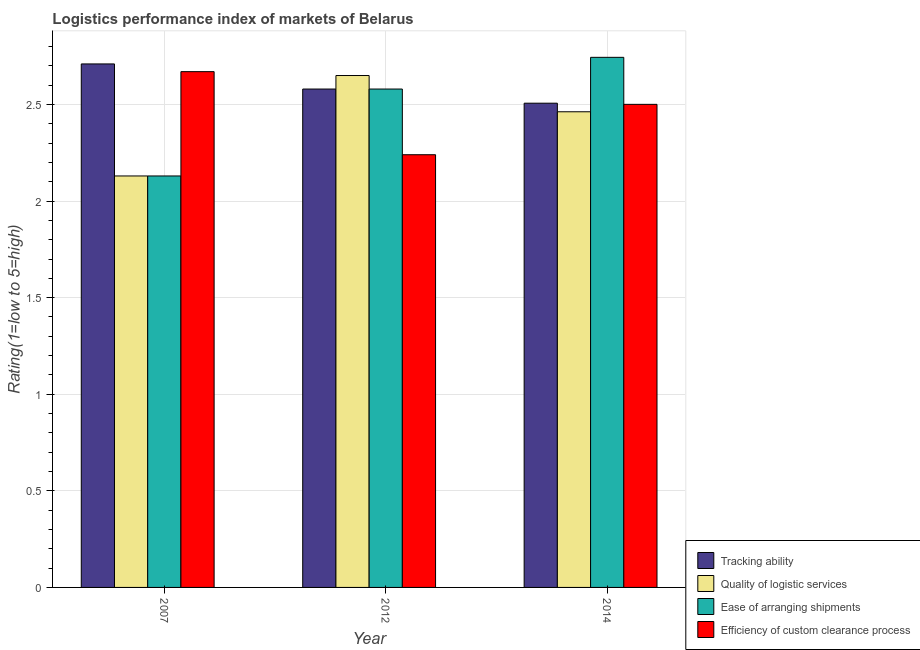How many different coloured bars are there?
Make the answer very short. 4. How many groups of bars are there?
Keep it short and to the point. 3. How many bars are there on the 3rd tick from the left?
Keep it short and to the point. 4. How many bars are there on the 3rd tick from the right?
Offer a very short reply. 4. In how many cases, is the number of bars for a given year not equal to the number of legend labels?
Ensure brevity in your answer.  0. What is the lpi rating of ease of arranging shipments in 2012?
Provide a succinct answer. 2.58. Across all years, what is the maximum lpi rating of ease of arranging shipments?
Offer a terse response. 2.74. Across all years, what is the minimum lpi rating of ease of arranging shipments?
Your response must be concise. 2.13. What is the total lpi rating of ease of arranging shipments in the graph?
Ensure brevity in your answer.  7.45. What is the difference between the lpi rating of ease of arranging shipments in 2007 and that in 2014?
Provide a succinct answer. -0.61. What is the difference between the lpi rating of efficiency of custom clearance process in 2014 and the lpi rating of ease of arranging shipments in 2007?
Your response must be concise. -0.17. What is the average lpi rating of ease of arranging shipments per year?
Your answer should be compact. 2.48. What is the ratio of the lpi rating of tracking ability in 2007 to that in 2012?
Provide a short and direct response. 1.05. Is the lpi rating of tracking ability in 2007 less than that in 2012?
Make the answer very short. No. What is the difference between the highest and the second highest lpi rating of quality of logistic services?
Provide a short and direct response. 0.19. What is the difference between the highest and the lowest lpi rating of quality of logistic services?
Offer a very short reply. 0.52. Is the sum of the lpi rating of ease of arranging shipments in 2007 and 2014 greater than the maximum lpi rating of efficiency of custom clearance process across all years?
Your response must be concise. Yes. Is it the case that in every year, the sum of the lpi rating of tracking ability and lpi rating of quality of logistic services is greater than the sum of lpi rating of efficiency of custom clearance process and lpi rating of ease of arranging shipments?
Keep it short and to the point. No. What does the 4th bar from the left in 2007 represents?
Your answer should be very brief. Efficiency of custom clearance process. What does the 2nd bar from the right in 2007 represents?
Offer a very short reply. Ease of arranging shipments. Is it the case that in every year, the sum of the lpi rating of tracking ability and lpi rating of quality of logistic services is greater than the lpi rating of ease of arranging shipments?
Keep it short and to the point. Yes. Are all the bars in the graph horizontal?
Make the answer very short. No. Does the graph contain any zero values?
Ensure brevity in your answer.  No. How are the legend labels stacked?
Your answer should be compact. Vertical. What is the title of the graph?
Provide a succinct answer. Logistics performance index of markets of Belarus. What is the label or title of the X-axis?
Your response must be concise. Year. What is the label or title of the Y-axis?
Your answer should be compact. Rating(1=low to 5=high). What is the Rating(1=low to 5=high) in Tracking ability in 2007?
Ensure brevity in your answer.  2.71. What is the Rating(1=low to 5=high) of Quality of logistic services in 2007?
Your answer should be compact. 2.13. What is the Rating(1=low to 5=high) in Ease of arranging shipments in 2007?
Make the answer very short. 2.13. What is the Rating(1=low to 5=high) of Efficiency of custom clearance process in 2007?
Offer a very short reply. 2.67. What is the Rating(1=low to 5=high) in Tracking ability in 2012?
Keep it short and to the point. 2.58. What is the Rating(1=low to 5=high) of Quality of logistic services in 2012?
Provide a succinct answer. 2.65. What is the Rating(1=low to 5=high) of Ease of arranging shipments in 2012?
Keep it short and to the point. 2.58. What is the Rating(1=low to 5=high) in Efficiency of custom clearance process in 2012?
Your response must be concise. 2.24. What is the Rating(1=low to 5=high) of Tracking ability in 2014?
Keep it short and to the point. 2.51. What is the Rating(1=low to 5=high) of Quality of logistic services in 2014?
Offer a terse response. 2.46. What is the Rating(1=low to 5=high) in Ease of arranging shipments in 2014?
Provide a short and direct response. 2.74. What is the Rating(1=low to 5=high) of Efficiency of custom clearance process in 2014?
Offer a very short reply. 2.5. Across all years, what is the maximum Rating(1=low to 5=high) of Tracking ability?
Your answer should be compact. 2.71. Across all years, what is the maximum Rating(1=low to 5=high) in Quality of logistic services?
Make the answer very short. 2.65. Across all years, what is the maximum Rating(1=low to 5=high) in Ease of arranging shipments?
Offer a very short reply. 2.74. Across all years, what is the maximum Rating(1=low to 5=high) in Efficiency of custom clearance process?
Your answer should be very brief. 2.67. Across all years, what is the minimum Rating(1=low to 5=high) of Tracking ability?
Your answer should be compact. 2.51. Across all years, what is the minimum Rating(1=low to 5=high) of Quality of logistic services?
Your answer should be very brief. 2.13. Across all years, what is the minimum Rating(1=low to 5=high) of Ease of arranging shipments?
Make the answer very short. 2.13. Across all years, what is the minimum Rating(1=low to 5=high) in Efficiency of custom clearance process?
Provide a short and direct response. 2.24. What is the total Rating(1=low to 5=high) of Tracking ability in the graph?
Offer a terse response. 7.8. What is the total Rating(1=low to 5=high) in Quality of logistic services in the graph?
Your response must be concise. 7.24. What is the total Rating(1=low to 5=high) of Ease of arranging shipments in the graph?
Offer a terse response. 7.45. What is the total Rating(1=low to 5=high) in Efficiency of custom clearance process in the graph?
Ensure brevity in your answer.  7.41. What is the difference between the Rating(1=low to 5=high) of Tracking ability in 2007 and that in 2012?
Keep it short and to the point. 0.13. What is the difference between the Rating(1=low to 5=high) of Quality of logistic services in 2007 and that in 2012?
Provide a succinct answer. -0.52. What is the difference between the Rating(1=low to 5=high) of Ease of arranging shipments in 2007 and that in 2012?
Provide a short and direct response. -0.45. What is the difference between the Rating(1=low to 5=high) in Efficiency of custom clearance process in 2007 and that in 2012?
Keep it short and to the point. 0.43. What is the difference between the Rating(1=low to 5=high) of Tracking ability in 2007 and that in 2014?
Offer a terse response. 0.2. What is the difference between the Rating(1=low to 5=high) in Quality of logistic services in 2007 and that in 2014?
Your answer should be very brief. -0.33. What is the difference between the Rating(1=low to 5=high) of Ease of arranging shipments in 2007 and that in 2014?
Provide a succinct answer. -0.61. What is the difference between the Rating(1=low to 5=high) of Efficiency of custom clearance process in 2007 and that in 2014?
Provide a succinct answer. 0.17. What is the difference between the Rating(1=low to 5=high) in Tracking ability in 2012 and that in 2014?
Your response must be concise. 0.07. What is the difference between the Rating(1=low to 5=high) in Quality of logistic services in 2012 and that in 2014?
Make the answer very short. 0.19. What is the difference between the Rating(1=low to 5=high) in Ease of arranging shipments in 2012 and that in 2014?
Your response must be concise. -0.16. What is the difference between the Rating(1=low to 5=high) in Efficiency of custom clearance process in 2012 and that in 2014?
Offer a terse response. -0.26. What is the difference between the Rating(1=low to 5=high) in Tracking ability in 2007 and the Rating(1=low to 5=high) in Ease of arranging shipments in 2012?
Offer a very short reply. 0.13. What is the difference between the Rating(1=low to 5=high) in Tracking ability in 2007 and the Rating(1=low to 5=high) in Efficiency of custom clearance process in 2012?
Make the answer very short. 0.47. What is the difference between the Rating(1=low to 5=high) of Quality of logistic services in 2007 and the Rating(1=low to 5=high) of Ease of arranging shipments in 2012?
Provide a succinct answer. -0.45. What is the difference between the Rating(1=low to 5=high) of Quality of logistic services in 2007 and the Rating(1=low to 5=high) of Efficiency of custom clearance process in 2012?
Provide a short and direct response. -0.11. What is the difference between the Rating(1=low to 5=high) of Ease of arranging shipments in 2007 and the Rating(1=low to 5=high) of Efficiency of custom clearance process in 2012?
Make the answer very short. -0.11. What is the difference between the Rating(1=low to 5=high) in Tracking ability in 2007 and the Rating(1=low to 5=high) in Quality of logistic services in 2014?
Ensure brevity in your answer.  0.25. What is the difference between the Rating(1=low to 5=high) in Tracking ability in 2007 and the Rating(1=low to 5=high) in Ease of arranging shipments in 2014?
Ensure brevity in your answer.  -0.03. What is the difference between the Rating(1=low to 5=high) of Tracking ability in 2007 and the Rating(1=low to 5=high) of Efficiency of custom clearance process in 2014?
Make the answer very short. 0.21. What is the difference between the Rating(1=low to 5=high) of Quality of logistic services in 2007 and the Rating(1=low to 5=high) of Ease of arranging shipments in 2014?
Make the answer very short. -0.61. What is the difference between the Rating(1=low to 5=high) in Quality of logistic services in 2007 and the Rating(1=low to 5=high) in Efficiency of custom clearance process in 2014?
Give a very brief answer. -0.37. What is the difference between the Rating(1=low to 5=high) of Ease of arranging shipments in 2007 and the Rating(1=low to 5=high) of Efficiency of custom clearance process in 2014?
Provide a short and direct response. -0.37. What is the difference between the Rating(1=low to 5=high) in Tracking ability in 2012 and the Rating(1=low to 5=high) in Quality of logistic services in 2014?
Give a very brief answer. 0.12. What is the difference between the Rating(1=low to 5=high) of Tracking ability in 2012 and the Rating(1=low to 5=high) of Ease of arranging shipments in 2014?
Offer a terse response. -0.16. What is the difference between the Rating(1=low to 5=high) in Tracking ability in 2012 and the Rating(1=low to 5=high) in Efficiency of custom clearance process in 2014?
Your answer should be compact. 0.08. What is the difference between the Rating(1=low to 5=high) of Quality of logistic services in 2012 and the Rating(1=low to 5=high) of Ease of arranging shipments in 2014?
Your answer should be very brief. -0.09. What is the difference between the Rating(1=low to 5=high) in Quality of logistic services in 2012 and the Rating(1=low to 5=high) in Efficiency of custom clearance process in 2014?
Give a very brief answer. 0.15. What is the difference between the Rating(1=low to 5=high) of Ease of arranging shipments in 2012 and the Rating(1=low to 5=high) of Efficiency of custom clearance process in 2014?
Make the answer very short. 0.08. What is the average Rating(1=low to 5=high) in Tracking ability per year?
Offer a very short reply. 2.6. What is the average Rating(1=low to 5=high) in Quality of logistic services per year?
Give a very brief answer. 2.41. What is the average Rating(1=low to 5=high) in Ease of arranging shipments per year?
Provide a short and direct response. 2.48. What is the average Rating(1=low to 5=high) of Efficiency of custom clearance process per year?
Your answer should be compact. 2.47. In the year 2007, what is the difference between the Rating(1=low to 5=high) in Tracking ability and Rating(1=low to 5=high) in Quality of logistic services?
Your response must be concise. 0.58. In the year 2007, what is the difference between the Rating(1=low to 5=high) of Tracking ability and Rating(1=low to 5=high) of Ease of arranging shipments?
Provide a short and direct response. 0.58. In the year 2007, what is the difference between the Rating(1=low to 5=high) in Quality of logistic services and Rating(1=low to 5=high) in Ease of arranging shipments?
Keep it short and to the point. 0. In the year 2007, what is the difference between the Rating(1=low to 5=high) of Quality of logistic services and Rating(1=low to 5=high) of Efficiency of custom clearance process?
Offer a very short reply. -0.54. In the year 2007, what is the difference between the Rating(1=low to 5=high) of Ease of arranging shipments and Rating(1=low to 5=high) of Efficiency of custom clearance process?
Give a very brief answer. -0.54. In the year 2012, what is the difference between the Rating(1=low to 5=high) of Tracking ability and Rating(1=low to 5=high) of Quality of logistic services?
Your answer should be compact. -0.07. In the year 2012, what is the difference between the Rating(1=low to 5=high) in Tracking ability and Rating(1=low to 5=high) in Ease of arranging shipments?
Give a very brief answer. 0. In the year 2012, what is the difference between the Rating(1=low to 5=high) of Tracking ability and Rating(1=low to 5=high) of Efficiency of custom clearance process?
Offer a terse response. 0.34. In the year 2012, what is the difference between the Rating(1=low to 5=high) of Quality of logistic services and Rating(1=low to 5=high) of Ease of arranging shipments?
Your answer should be very brief. 0.07. In the year 2012, what is the difference between the Rating(1=low to 5=high) of Quality of logistic services and Rating(1=low to 5=high) of Efficiency of custom clearance process?
Give a very brief answer. 0.41. In the year 2012, what is the difference between the Rating(1=low to 5=high) of Ease of arranging shipments and Rating(1=low to 5=high) of Efficiency of custom clearance process?
Your answer should be very brief. 0.34. In the year 2014, what is the difference between the Rating(1=low to 5=high) in Tracking ability and Rating(1=low to 5=high) in Quality of logistic services?
Give a very brief answer. 0.04. In the year 2014, what is the difference between the Rating(1=low to 5=high) in Tracking ability and Rating(1=low to 5=high) in Ease of arranging shipments?
Your answer should be very brief. -0.24. In the year 2014, what is the difference between the Rating(1=low to 5=high) of Tracking ability and Rating(1=low to 5=high) of Efficiency of custom clearance process?
Your response must be concise. 0.01. In the year 2014, what is the difference between the Rating(1=low to 5=high) in Quality of logistic services and Rating(1=low to 5=high) in Ease of arranging shipments?
Offer a terse response. -0.28. In the year 2014, what is the difference between the Rating(1=low to 5=high) in Quality of logistic services and Rating(1=low to 5=high) in Efficiency of custom clearance process?
Ensure brevity in your answer.  -0.04. In the year 2014, what is the difference between the Rating(1=low to 5=high) in Ease of arranging shipments and Rating(1=low to 5=high) in Efficiency of custom clearance process?
Your response must be concise. 0.24. What is the ratio of the Rating(1=low to 5=high) of Tracking ability in 2007 to that in 2012?
Provide a short and direct response. 1.05. What is the ratio of the Rating(1=low to 5=high) in Quality of logistic services in 2007 to that in 2012?
Your answer should be very brief. 0.8. What is the ratio of the Rating(1=low to 5=high) of Ease of arranging shipments in 2007 to that in 2012?
Your answer should be very brief. 0.83. What is the ratio of the Rating(1=low to 5=high) in Efficiency of custom clearance process in 2007 to that in 2012?
Make the answer very short. 1.19. What is the ratio of the Rating(1=low to 5=high) in Tracking ability in 2007 to that in 2014?
Keep it short and to the point. 1.08. What is the ratio of the Rating(1=low to 5=high) in Quality of logistic services in 2007 to that in 2014?
Your response must be concise. 0.86. What is the ratio of the Rating(1=low to 5=high) in Ease of arranging shipments in 2007 to that in 2014?
Your answer should be very brief. 0.78. What is the ratio of the Rating(1=low to 5=high) of Efficiency of custom clearance process in 2007 to that in 2014?
Offer a terse response. 1.07. What is the ratio of the Rating(1=low to 5=high) of Tracking ability in 2012 to that in 2014?
Your answer should be compact. 1.03. What is the ratio of the Rating(1=low to 5=high) of Quality of logistic services in 2012 to that in 2014?
Ensure brevity in your answer.  1.08. What is the ratio of the Rating(1=low to 5=high) in Ease of arranging shipments in 2012 to that in 2014?
Ensure brevity in your answer.  0.94. What is the ratio of the Rating(1=low to 5=high) of Efficiency of custom clearance process in 2012 to that in 2014?
Your answer should be compact. 0.9. What is the difference between the highest and the second highest Rating(1=low to 5=high) in Tracking ability?
Your response must be concise. 0.13. What is the difference between the highest and the second highest Rating(1=low to 5=high) in Quality of logistic services?
Make the answer very short. 0.19. What is the difference between the highest and the second highest Rating(1=low to 5=high) in Ease of arranging shipments?
Make the answer very short. 0.16. What is the difference between the highest and the second highest Rating(1=low to 5=high) of Efficiency of custom clearance process?
Provide a short and direct response. 0.17. What is the difference between the highest and the lowest Rating(1=low to 5=high) in Tracking ability?
Your answer should be very brief. 0.2. What is the difference between the highest and the lowest Rating(1=low to 5=high) in Quality of logistic services?
Ensure brevity in your answer.  0.52. What is the difference between the highest and the lowest Rating(1=low to 5=high) in Ease of arranging shipments?
Keep it short and to the point. 0.61. What is the difference between the highest and the lowest Rating(1=low to 5=high) of Efficiency of custom clearance process?
Provide a short and direct response. 0.43. 